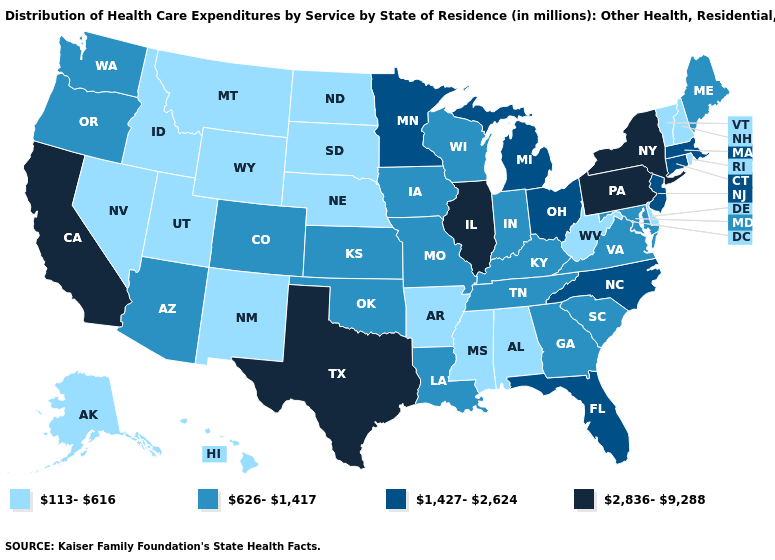Name the states that have a value in the range 113-616?
Answer briefly. Alabama, Alaska, Arkansas, Delaware, Hawaii, Idaho, Mississippi, Montana, Nebraska, Nevada, New Hampshire, New Mexico, North Dakota, Rhode Island, South Dakota, Utah, Vermont, West Virginia, Wyoming. What is the value of North Dakota?
Concise answer only. 113-616. How many symbols are there in the legend?
Give a very brief answer. 4. What is the value of Ohio?
Quick response, please. 1,427-2,624. Name the states that have a value in the range 113-616?
Be succinct. Alabama, Alaska, Arkansas, Delaware, Hawaii, Idaho, Mississippi, Montana, Nebraska, Nevada, New Hampshire, New Mexico, North Dakota, Rhode Island, South Dakota, Utah, Vermont, West Virginia, Wyoming. Does the first symbol in the legend represent the smallest category?
Short answer required. Yes. Among the states that border Utah , does Colorado have the highest value?
Give a very brief answer. Yes. Among the states that border Iowa , which have the highest value?
Keep it brief. Illinois. What is the value of Maryland?
Keep it brief. 626-1,417. Which states have the lowest value in the MidWest?
Be succinct. Nebraska, North Dakota, South Dakota. Name the states that have a value in the range 2,836-9,288?
Give a very brief answer. California, Illinois, New York, Pennsylvania, Texas. Which states have the lowest value in the USA?
Concise answer only. Alabama, Alaska, Arkansas, Delaware, Hawaii, Idaho, Mississippi, Montana, Nebraska, Nevada, New Hampshire, New Mexico, North Dakota, Rhode Island, South Dakota, Utah, Vermont, West Virginia, Wyoming. Is the legend a continuous bar?
Be succinct. No. Does Maine have the highest value in the Northeast?
Quick response, please. No. Does Nebraska have a lower value than New Jersey?
Write a very short answer. Yes. 